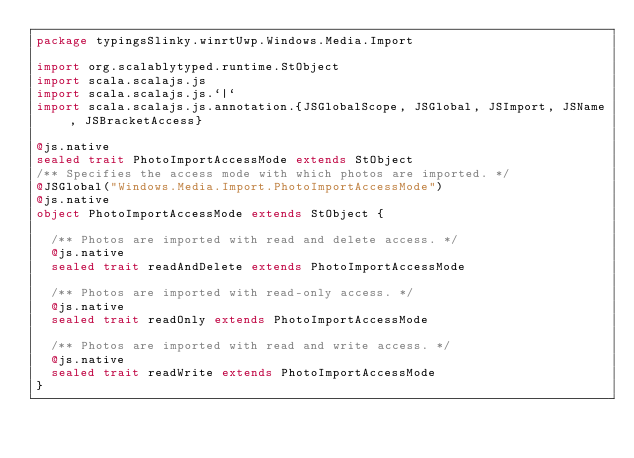<code> <loc_0><loc_0><loc_500><loc_500><_Scala_>package typingsSlinky.winrtUwp.Windows.Media.Import

import org.scalablytyped.runtime.StObject
import scala.scalajs.js
import scala.scalajs.js.`|`
import scala.scalajs.js.annotation.{JSGlobalScope, JSGlobal, JSImport, JSName, JSBracketAccess}

@js.native
sealed trait PhotoImportAccessMode extends StObject
/** Specifies the access mode with which photos are imported. */
@JSGlobal("Windows.Media.Import.PhotoImportAccessMode")
@js.native
object PhotoImportAccessMode extends StObject {
  
  /** Photos are imported with read and delete access. */
  @js.native
  sealed trait readAndDelete extends PhotoImportAccessMode
  
  /** Photos are imported with read-only access. */
  @js.native
  sealed trait readOnly extends PhotoImportAccessMode
  
  /** Photos are imported with read and write access. */
  @js.native
  sealed trait readWrite extends PhotoImportAccessMode
}
</code> 